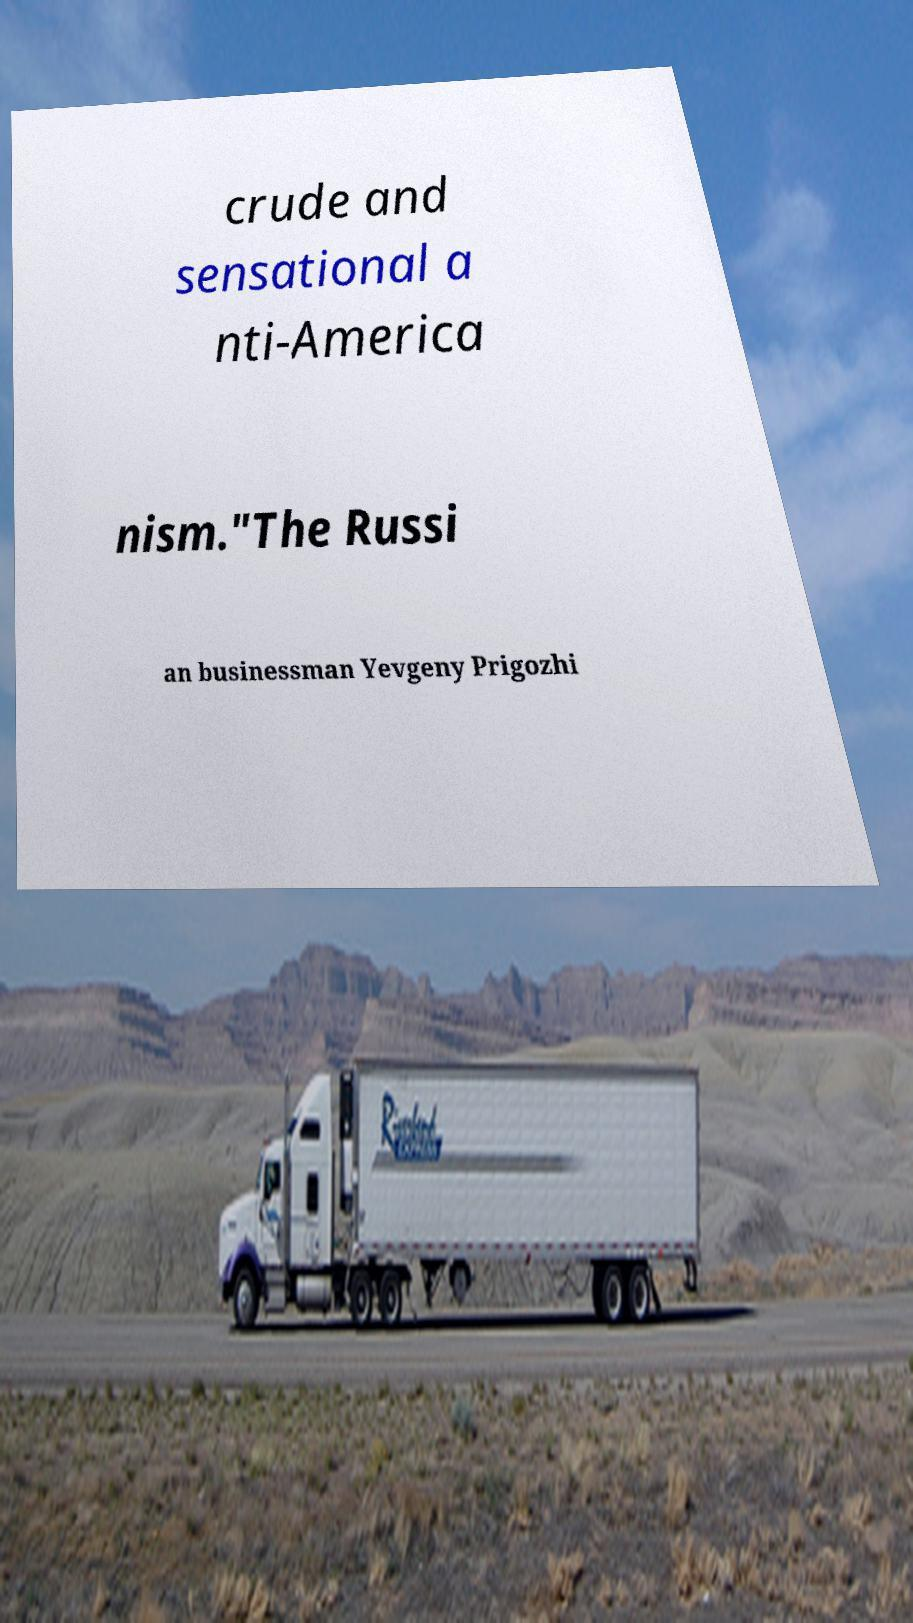There's text embedded in this image that I need extracted. Can you transcribe it verbatim? crude and sensational a nti-America nism."The Russi an businessman Yevgeny Prigozhi 